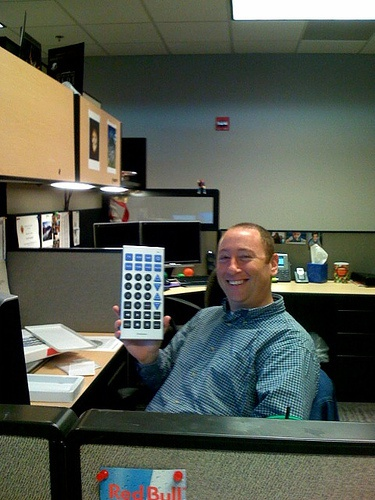Describe the objects in this image and their specific colors. I can see people in darkgreen, blue, gray, and black tones, tv in darkgreen, gray, and black tones, remote in darkgreen, lightblue, black, and gray tones, tv in darkgreen, black, darkgray, gray, and lightgray tones, and tv in darkgreen, black, gray, and lightgray tones in this image. 